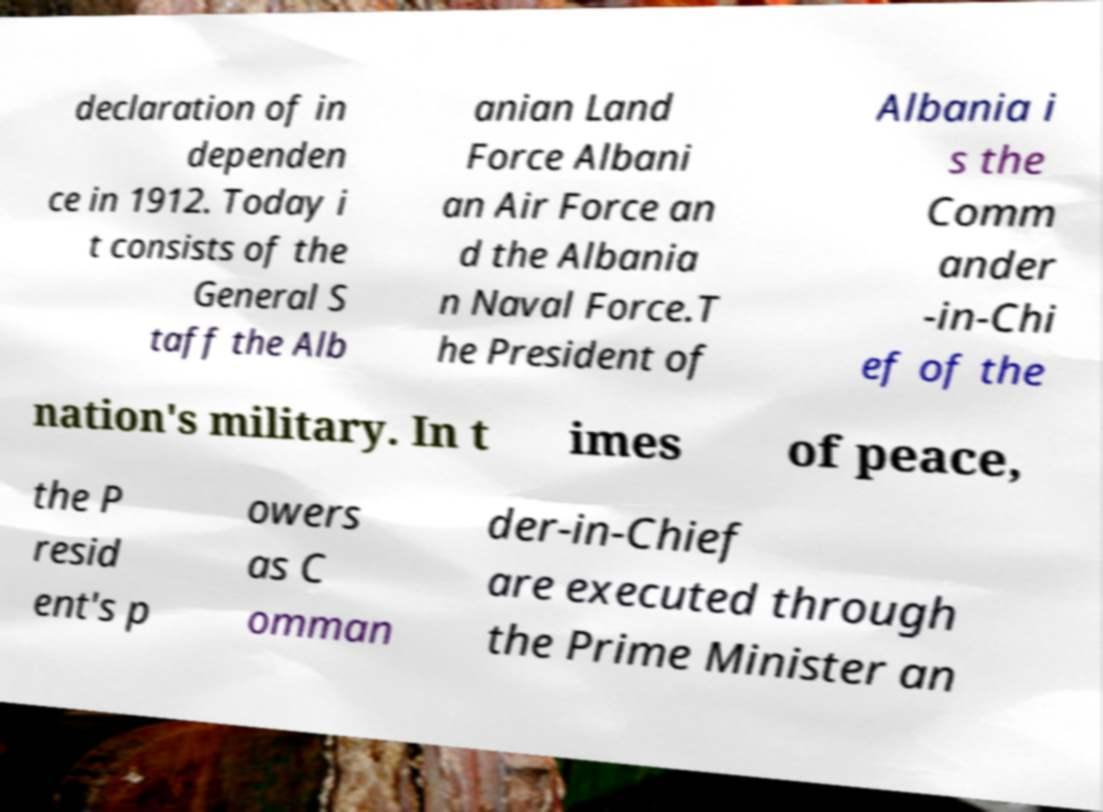For documentation purposes, I need the text within this image transcribed. Could you provide that? declaration of in dependen ce in 1912. Today i t consists of the General S taff the Alb anian Land Force Albani an Air Force an d the Albania n Naval Force.T he President of Albania i s the Comm ander -in-Chi ef of the nation's military. In t imes of peace, the P resid ent's p owers as C omman der-in-Chief are executed through the Prime Minister an 